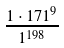Convert formula to latex. <formula><loc_0><loc_0><loc_500><loc_500>\frac { 1 \cdot 1 7 1 ^ { 9 } } { 1 ^ { 1 9 8 } }</formula> 